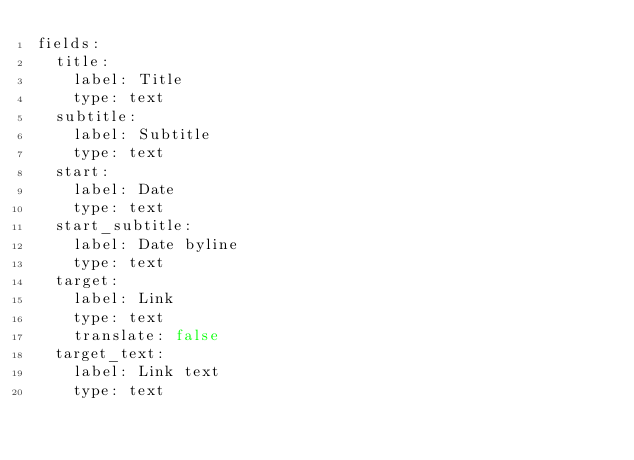Convert code to text. <code><loc_0><loc_0><loc_500><loc_500><_YAML_>fields:
  title:
    label: Title
    type: text
  subtitle:
    label: Subtitle
    type: text
  start:
    label: Date
    type: text
  start_subtitle:
    label: Date byline
    type: text
  target:
    label: Link
    type: text
    translate: false
  target_text:
    label: Link text
    type: text</code> 